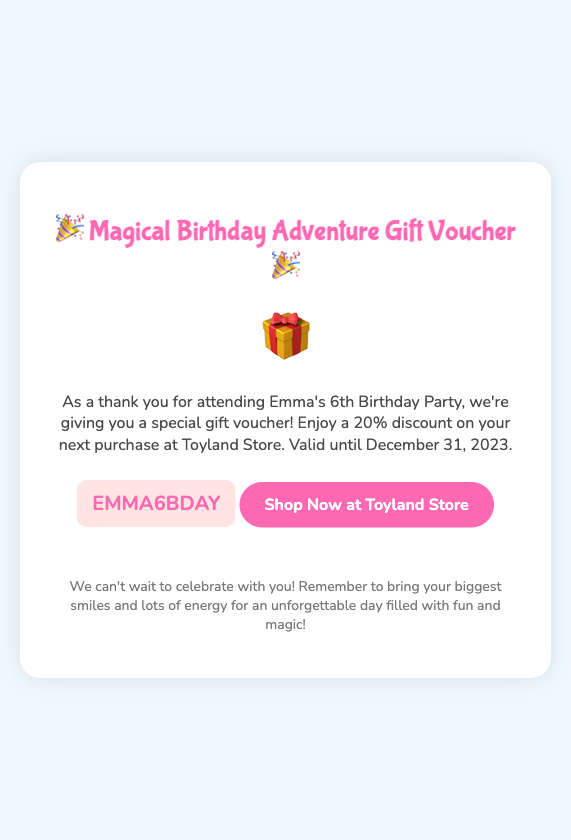What is the title of the gift voucher? The title is prominently displayed at the top of the document and is "Magical Birthday Adventure Gift Voucher".
Answer: Magical Birthday Adventure Gift Voucher Who is the birthday party for? The document states that the voucher is associated with a birthday party for Emma, which is mentioned in the description.
Answer: Emma What is the discount percentage offered in the voucher? The description clearly states that the voucher offers a 20% discount on the next purchase at the Toyland Store.
Answer: 20% When is the voucher valid until? The document specifies the validity date for the voucher, which is indicated as December 31, 2023.
Answer: December 31, 2023 What is the voucher code? The document displays the code prominently for users to use, which is "EMMA6BDAY".
Answer: EMMA6BDAY What type of store is the voucher redeemable at? The description informs us that this voucher is redeemable at the Toyland Store.
Answer: Toyland Store What is encouraged to bring to the birthday party? The footer mentions that guests should bring their biggest smiles and lots of energy for the celebration.
Answer: Smiles and energy What color is the background of the voucher? The body style of the document indicates that the background color is light blue (#f0f8ff).
Answer: Light blue 